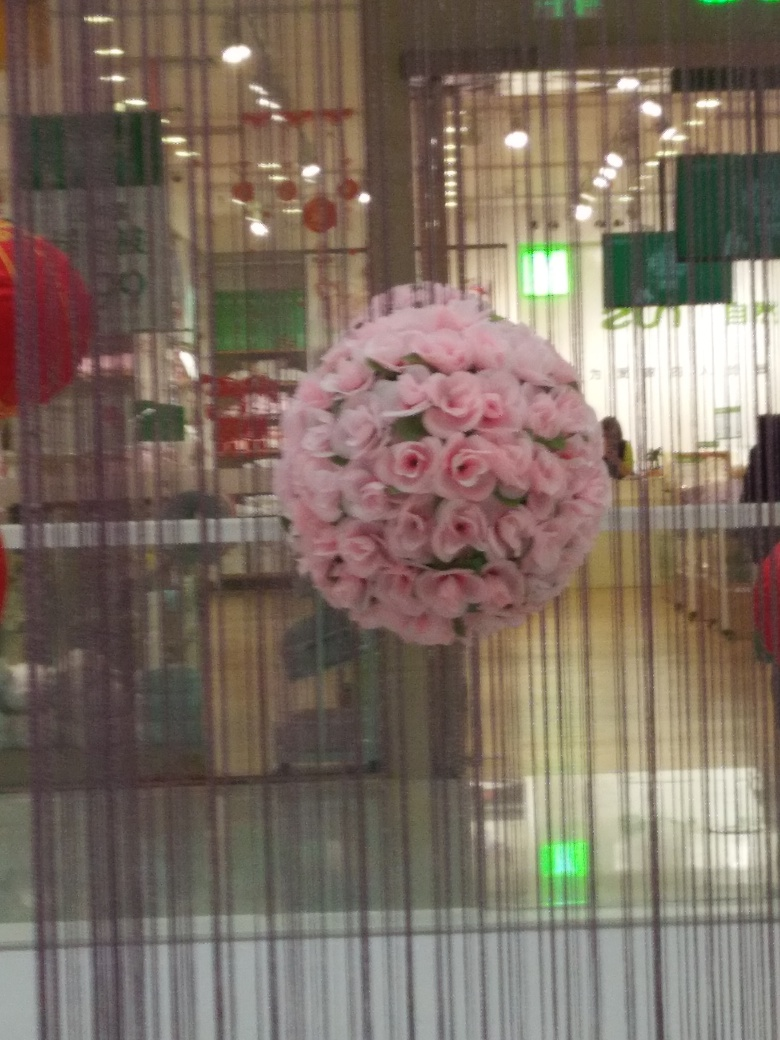How is the subject of this photo? The image features a spherical arrangement of pink roses suspended in mid-air in what appears to be a retail or commercial setting, characterized by a blurry appearance likely due to camera movement or focus issues. 